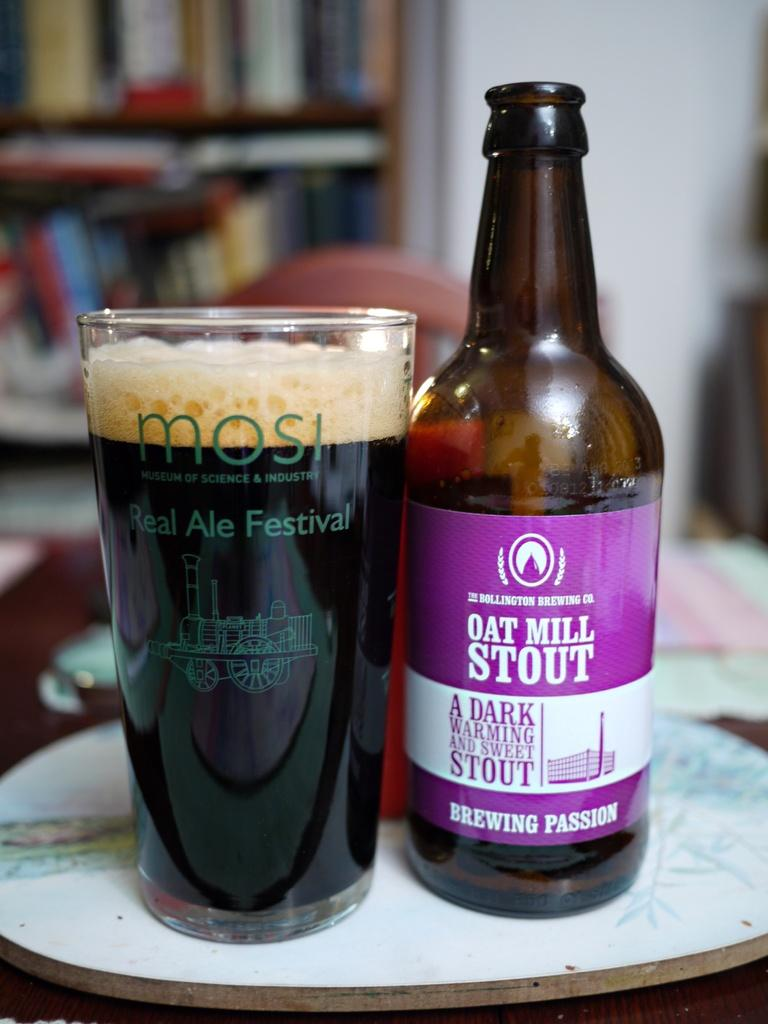<image>
Offer a succinct explanation of the picture presented. A bottle with the brand name Oat Mill Stout is next to a full glass on a table. 